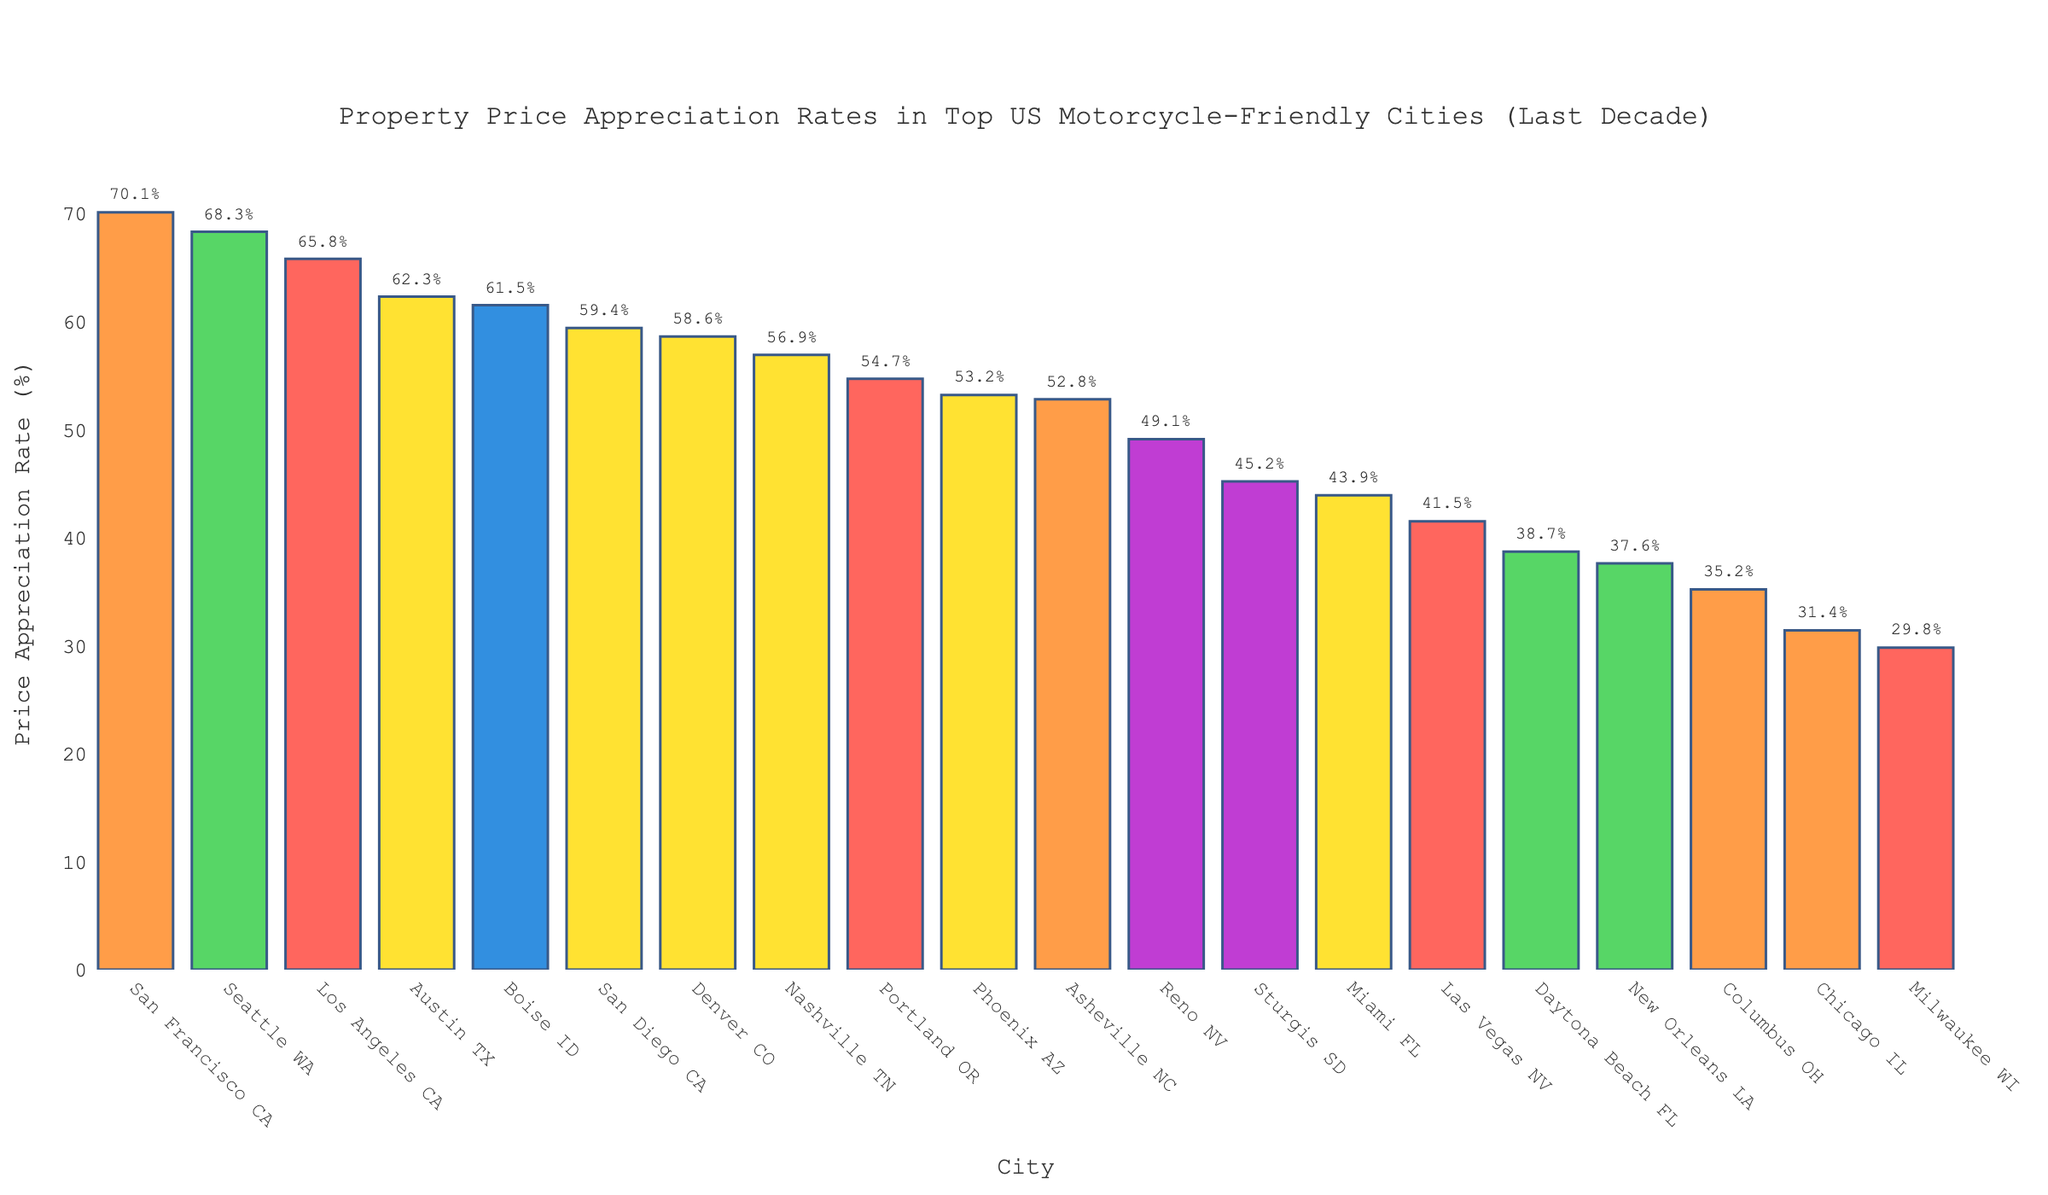What's the city with the highest property price appreciation rate over the last decade? The tallest bar represents the city with the highest property price appreciation rate. "San Francisco CA" has the highest bar with 70.1%.
Answer: San Francisco CA Which city has the second-highest appreciation rate, and what is it? Look for the second tallest bar. "Seattle WA" is the second tallest with a 68.3% appreciation rate.
Answer: Seattle WA, 68.3% How much higher is the property price appreciation rate in San Francisco CA compared to Milwaukee WI? Subtract the appreciation rate of Milwaukee WI from that of San Francisco CA. 70.1% - 29.8% = 40.3%.
Answer: 40.3% What's the average property price appreciation rate in Daytona Beach FL, New Orleans LA, and Columbus OH? Add the appreciation rates of the three cities and divide by 3. (38.7% + 37.6% + 35.2%) / 3 = 37.17%.
Answer: 37.2% What's the combined appreciation rate of Las Vegas NV and Reno NV? Add the appreciation rates of the two cities. 41.5% + 49.1% = 90.6%.
Answer: 90.6% Which city has the lowest property price appreciation rate, and what is it? The shortest bar represents the city with the lowest property price appreciation rate. "Milwaukee WI" has the shortest bar with 29.8%.
Answer: Milwaukee WI, 29.8% Arrange Austin TX, Asheville NC, and Denver CO in descending order of appreciation rates. Compare the heights of the bars for the three cities. Austin TX (62.3%), Denver CO (58.6%), and Asheville NC (52.8%).
Answer: Austin TX, Denver CO, Asheville NC What is the difference between the appreciation rates in Seattle WA and San Diego CA? Subtract the appreciation rate of San Diego CA from that of Seattle WA. 68.3% - 59.4% = 8.9%.
Answer: 8.9% Among the top 5 cities in appreciation rates, which one is the only city from Florida? Identify the top 5 cities by appreciation rates and check for the one from Florida. Among San Francisco CA, Seattle WA, Los Angeles CA, Austin TX, and Denver CO, none are from Florida. Therefore, consider top 10 and check. Daytona Beach FL (6th) is the only top 10 from Florida.
Answer: Daytona Beach FL 